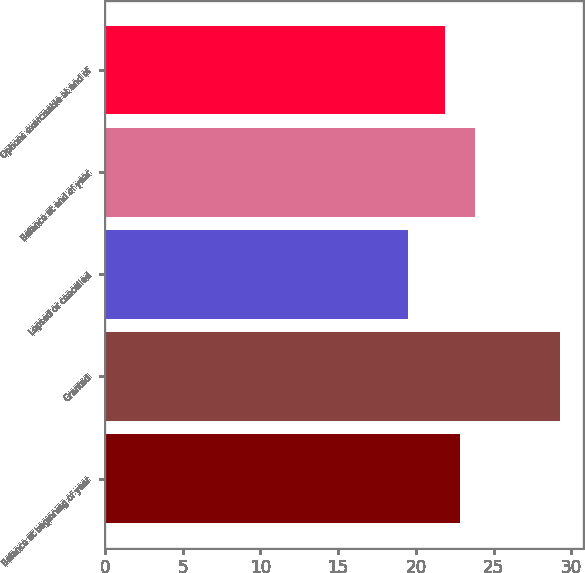Convert chart. <chart><loc_0><loc_0><loc_500><loc_500><bar_chart><fcel>Balance at beginning of year<fcel>Granted<fcel>Lapsed or cancelled<fcel>Balance at end of year<fcel>Options exercisable at end of<nl><fcel>22.83<fcel>29.28<fcel>19.49<fcel>23.81<fcel>21.85<nl></chart> 